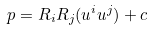Convert formula to latex. <formula><loc_0><loc_0><loc_500><loc_500>p = R _ { i } R _ { j } ( u ^ { i } u ^ { j } ) + c</formula> 